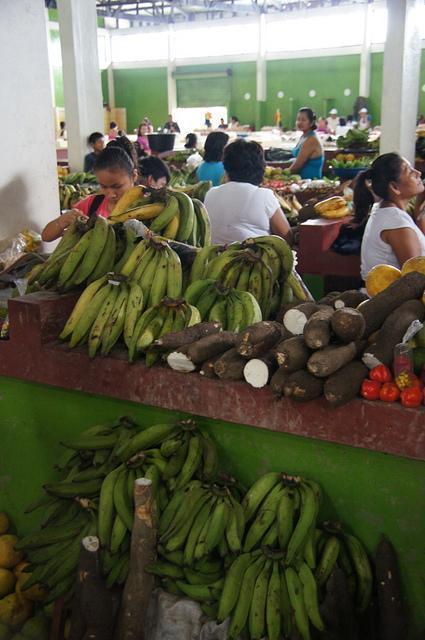How many bananas can be seen?
Give a very brief answer. 11. How many people can be seen?
Give a very brief answer. 3. 